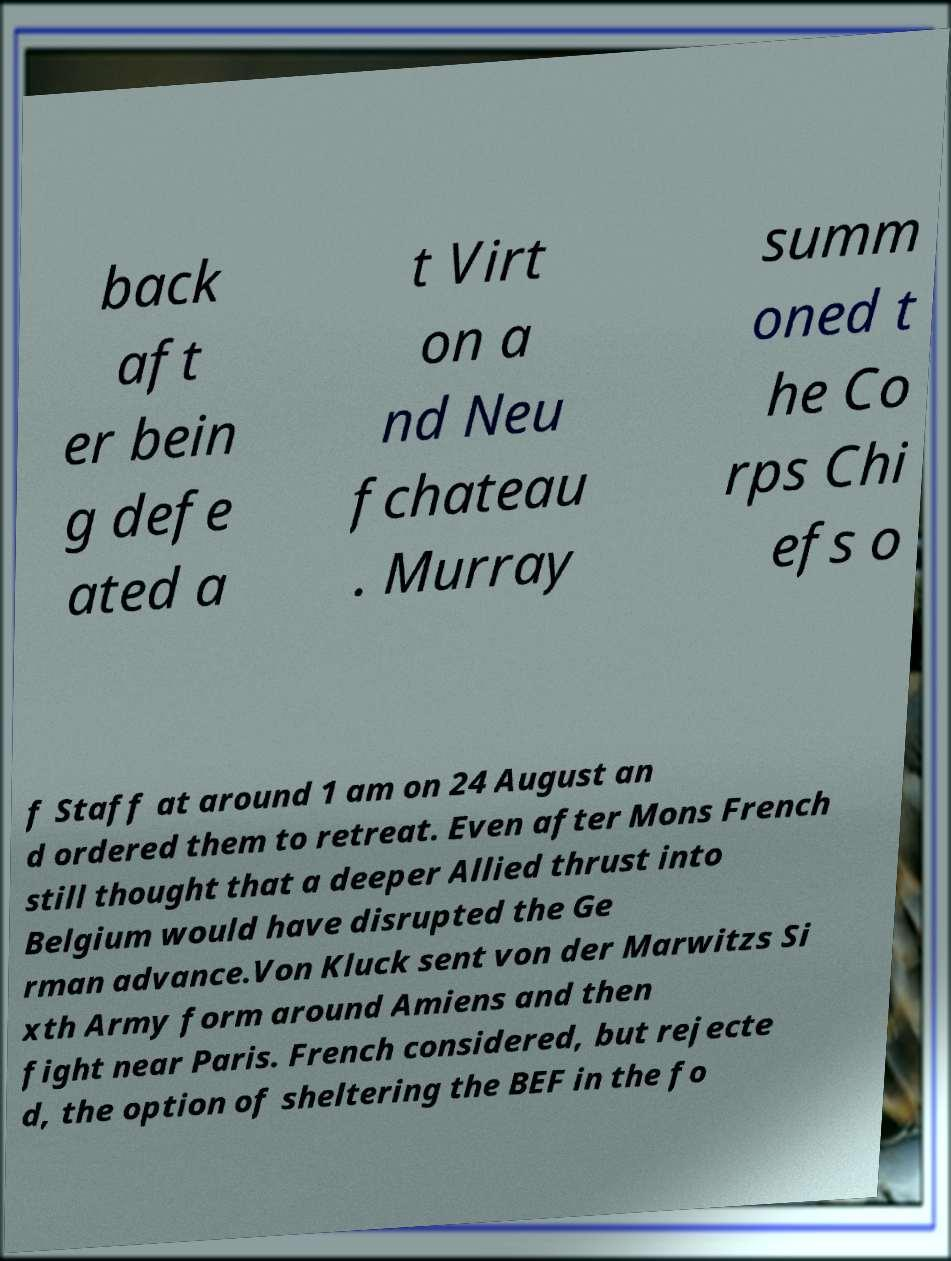For documentation purposes, I need the text within this image transcribed. Could you provide that? back aft er bein g defe ated a t Virt on a nd Neu fchateau . Murray summ oned t he Co rps Chi efs o f Staff at around 1 am on 24 August an d ordered them to retreat. Even after Mons French still thought that a deeper Allied thrust into Belgium would have disrupted the Ge rman advance.Von Kluck sent von der Marwitzs Si xth Army form around Amiens and then fight near Paris. French considered, but rejecte d, the option of sheltering the BEF in the fo 